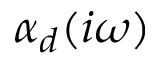Convert formula to latex. <formula><loc_0><loc_0><loc_500><loc_500>\alpha _ { d } ( i \omega )</formula> 